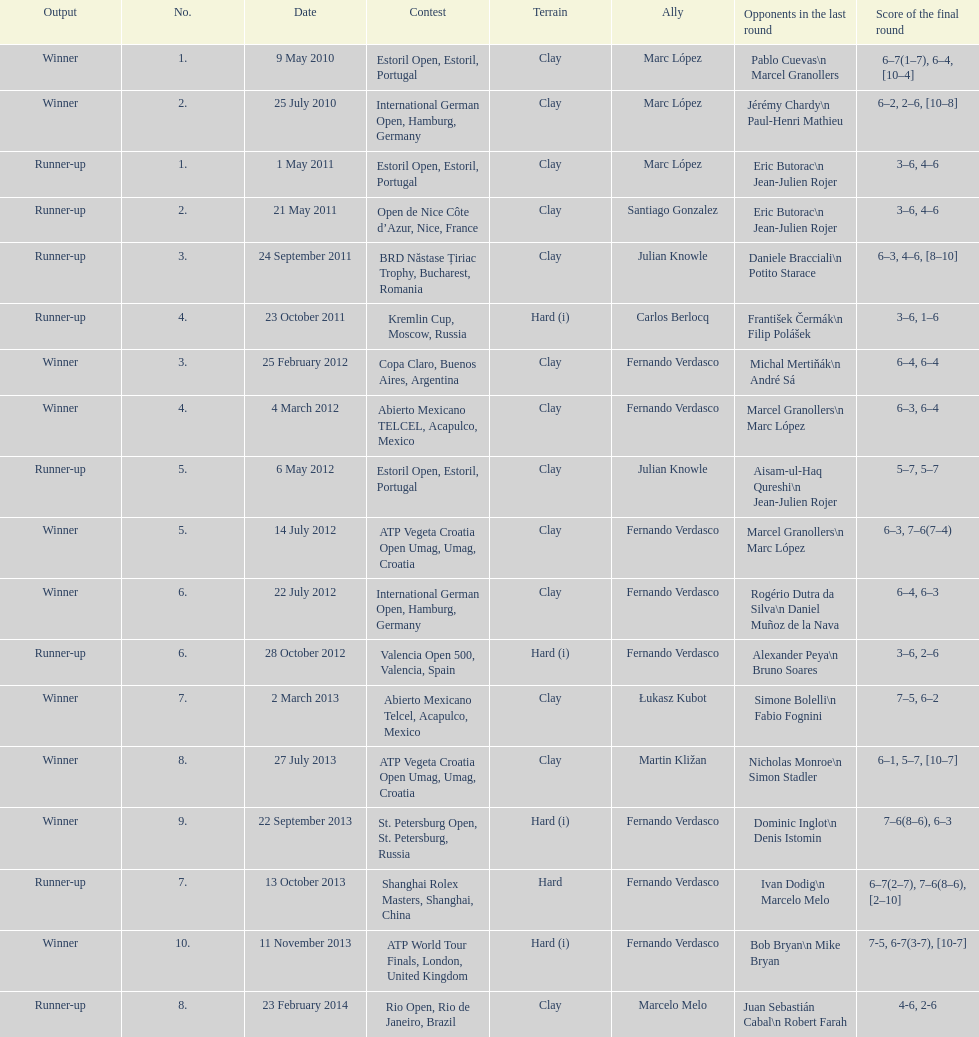What is the number of times a hard surface was used? 5. 